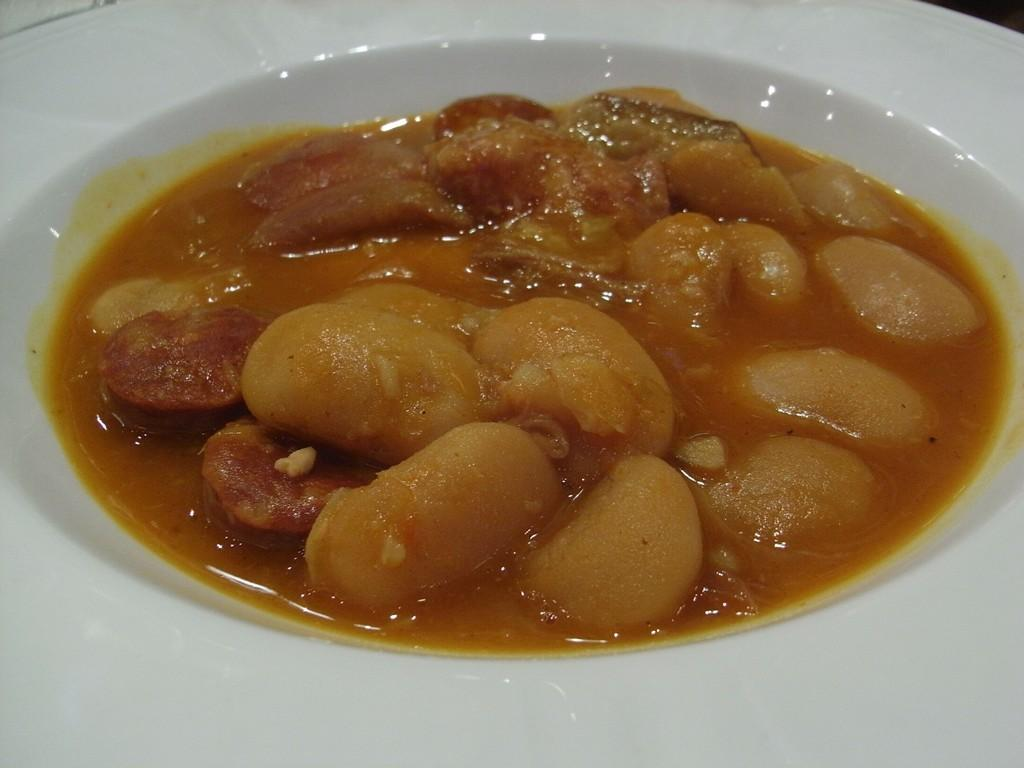What is present in the image that can be eaten? There is food in the image. How is the food arranged or contained in the image? The food is in a plate. What is the color of the food in the image? The food has a brown color. What type of shoes can be seen in the image? There are no shoes present in the image. What type of account is being discussed in the image? There is no account being discussed in the image. 